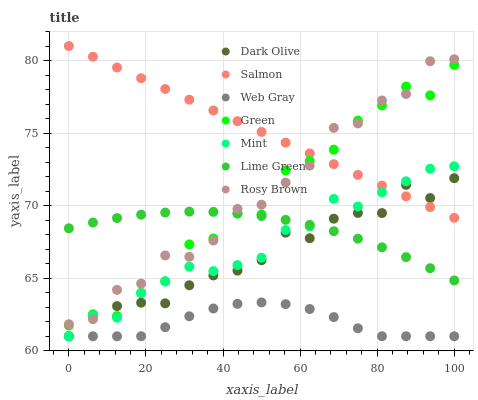Does Web Gray have the minimum area under the curve?
Answer yes or no. Yes. Does Salmon have the maximum area under the curve?
Answer yes or no. Yes. Does Lime Green have the minimum area under the curve?
Answer yes or no. No. Does Lime Green have the maximum area under the curve?
Answer yes or no. No. Is Salmon the smoothest?
Answer yes or no. Yes. Is Green the roughest?
Answer yes or no. Yes. Is Lime Green the smoothest?
Answer yes or no. No. Is Lime Green the roughest?
Answer yes or no. No. Does Web Gray have the lowest value?
Answer yes or no. Yes. Does Lime Green have the lowest value?
Answer yes or no. No. Does Salmon have the highest value?
Answer yes or no. Yes. Does Lime Green have the highest value?
Answer yes or no. No. Is Web Gray less than Salmon?
Answer yes or no. Yes. Is Rosy Brown greater than Web Gray?
Answer yes or no. Yes. Does Salmon intersect Mint?
Answer yes or no. Yes. Is Salmon less than Mint?
Answer yes or no. No. Is Salmon greater than Mint?
Answer yes or no. No. Does Web Gray intersect Salmon?
Answer yes or no. No. 